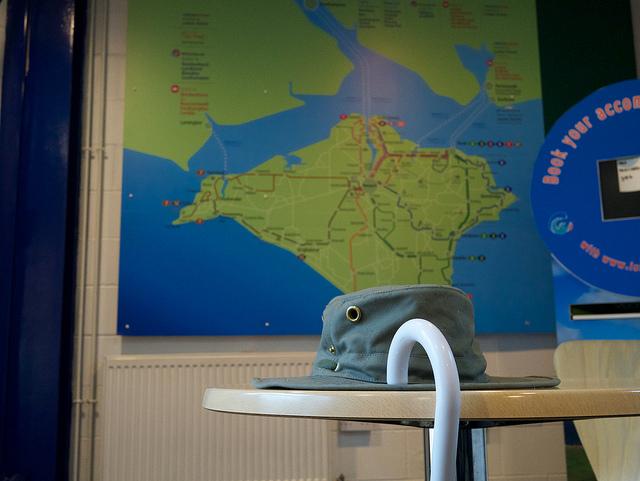What is the map of?
Quick response, please. England. Is the table made of oak?
Keep it brief. No. What is hanging off the table?
Answer briefly. Cane. Is there an animal in the image?
Answer briefly. No. What color is this hat?
Keep it brief. Blue. 